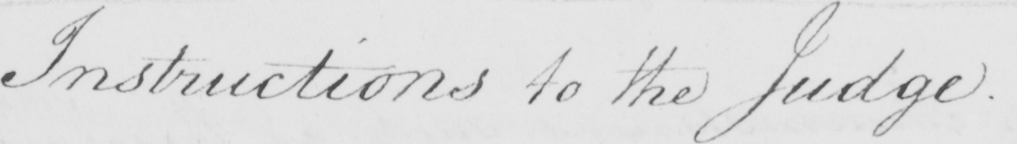What text is written in this handwritten line? Instructions to the Judge . 